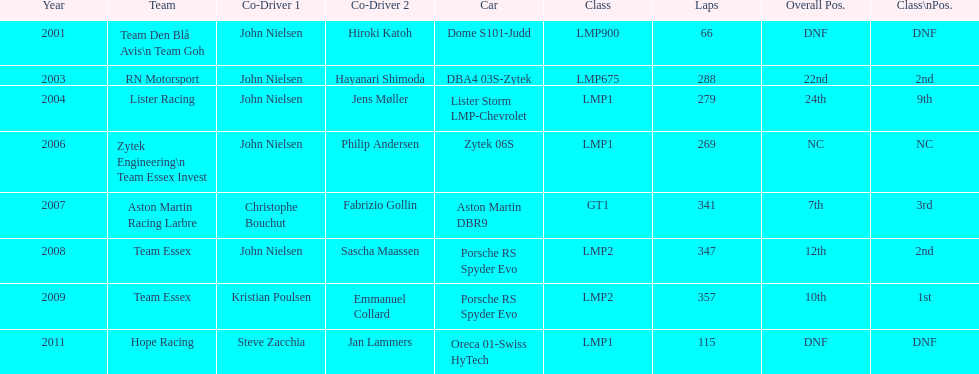What is the amount races that were competed in? 8. 